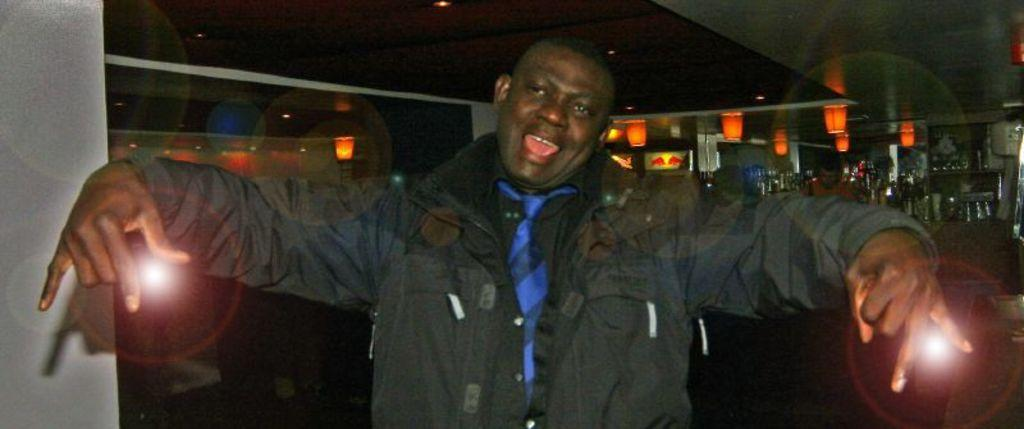What is the person in the front of the image doing? The person in the front of the image is standing and smiling. What can be seen in the background of the image? In the background of the image, there are bottles and glasses, lights, and another person. Can you describe the other person in the background? The other person in the background is not clearly visible, but they are present in the image. What year is the person in the image celebrating in the image? The provided facts do not mention any specific year, so it cannot be determined from the image. 